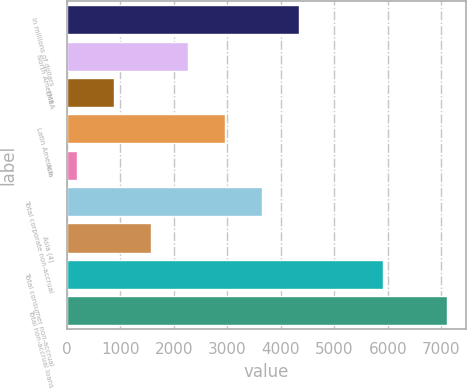<chart> <loc_0><loc_0><loc_500><loc_500><bar_chart><fcel>In millions of dollars<fcel>North America<fcel>EMEA<fcel>Latin America<fcel>Asia<fcel>Total corporate non-accrual<fcel>Asia (4)<fcel>Total consumer non-accrual<fcel>Total non-accrual loans<nl><fcel>4335.8<fcel>2257.4<fcel>871.8<fcel>2950.2<fcel>179<fcel>3643<fcel>1564.6<fcel>5905<fcel>7107<nl></chart> 